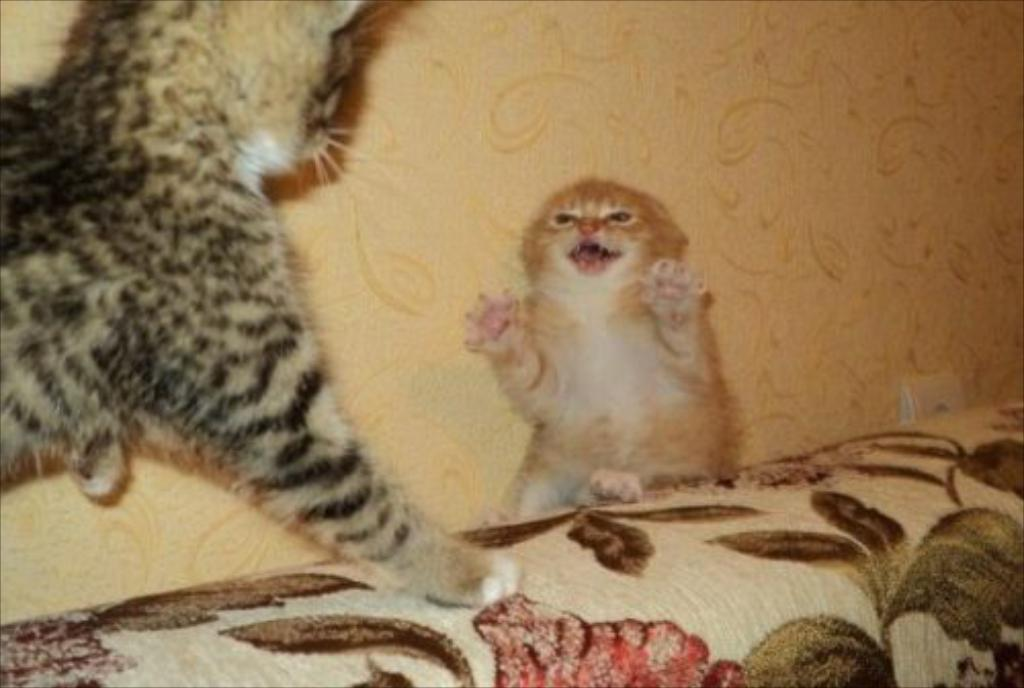What type of animal is in the image? There is a cat in the image. Where is the cat located? The cat is on a sofa. What is near the cat in the image? The cat is near a wall. What type of brass instrument is the cat playing in the image? There is no brass instrument present in the image, and the cat is not playing any instrument. 